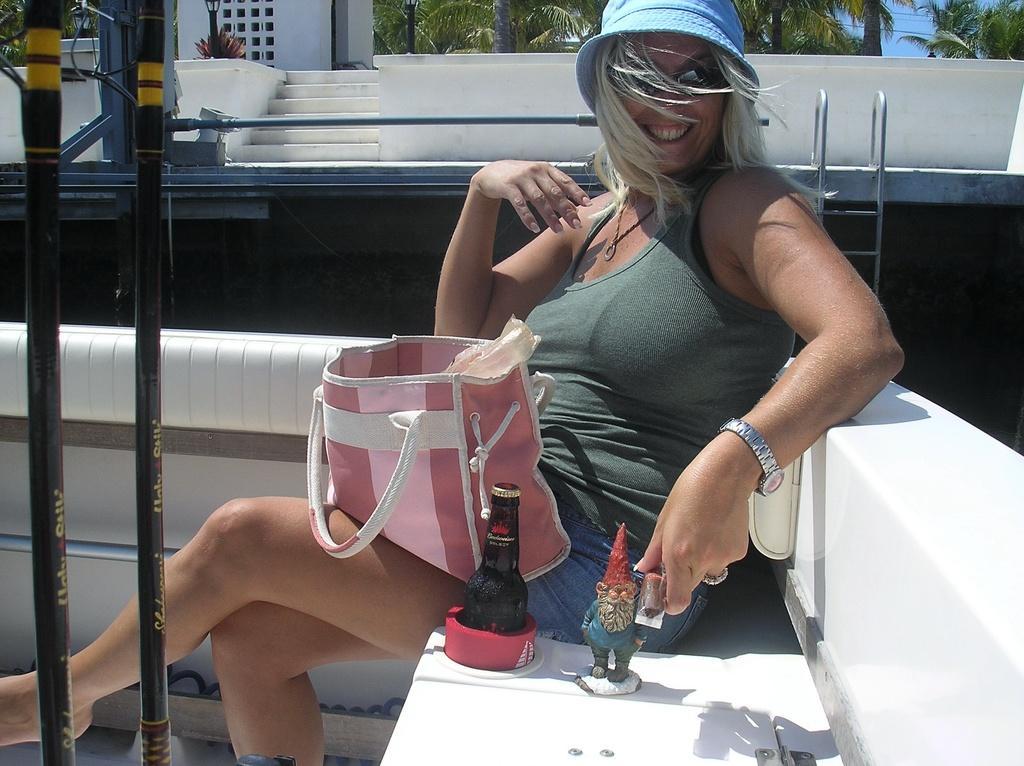Can you describe this image briefly? In this picture there is a lady who is sitting at the center of the image and there is a hand bag on her laps, there are some trees around the area of the image and there are stairs at the left side of the image and there is a ladder at the right side of the image, it seems to be a ship, there is a bottle and a toy beside her. 